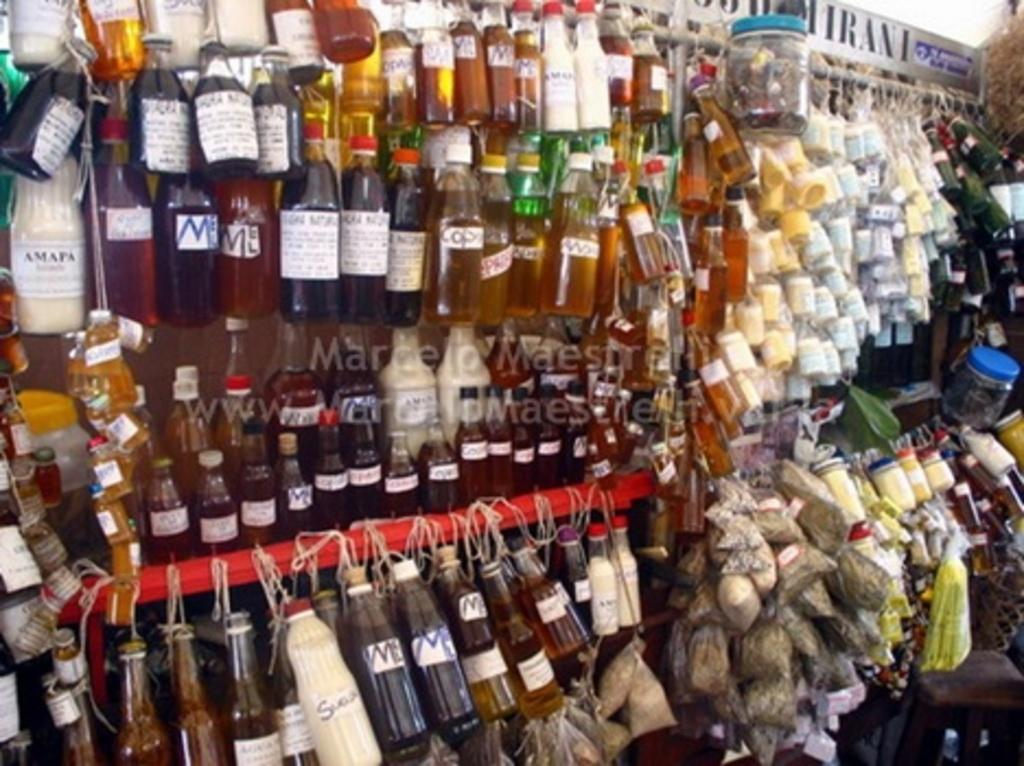What type of items can be seen in the image? There are bottles, packets, and containers in the image. Can you describe any other objects present in the image? Yes, there are other objects in the image. What is the income of the person who owns these items in the image? There is no information about the income of any person in the image, as it only shows various objects. What type of trade is being conducted in the image? There is no indication of any trade being conducted in the image, as it only shows various objects. 